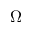<formula> <loc_0><loc_0><loc_500><loc_500>\Omega</formula> 